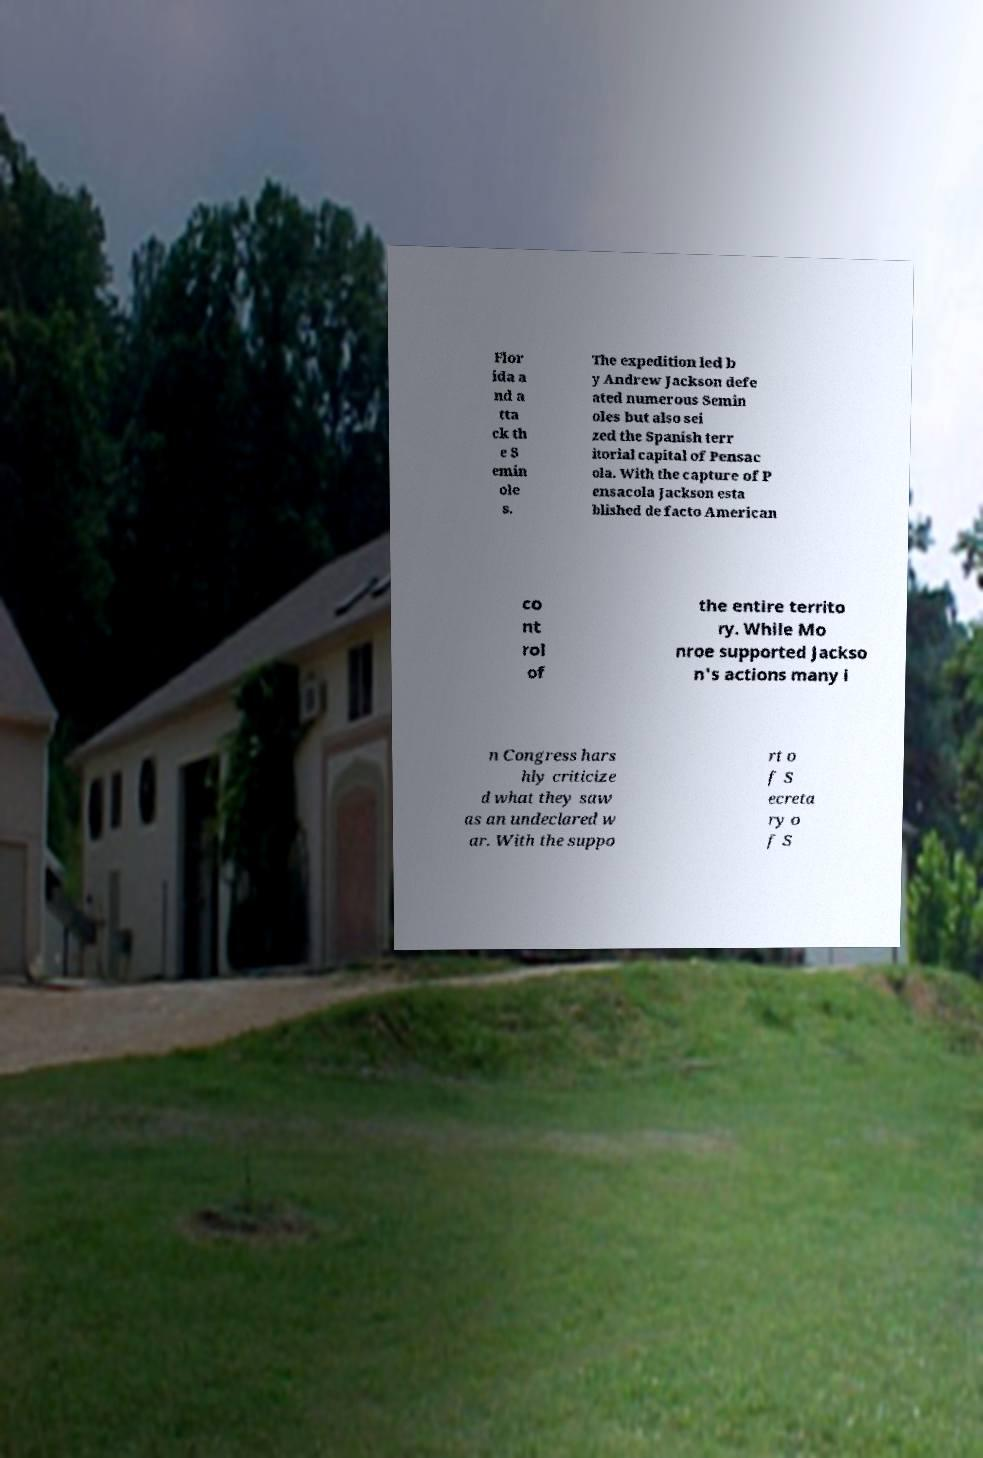Please read and relay the text visible in this image. What does it say? Flor ida a nd a tta ck th e S emin ole s. The expedition led b y Andrew Jackson defe ated numerous Semin oles but also sei zed the Spanish terr itorial capital of Pensac ola. With the capture of P ensacola Jackson esta blished de facto American co nt rol of the entire territo ry. While Mo nroe supported Jackso n's actions many i n Congress hars hly criticize d what they saw as an undeclared w ar. With the suppo rt o f S ecreta ry o f S 